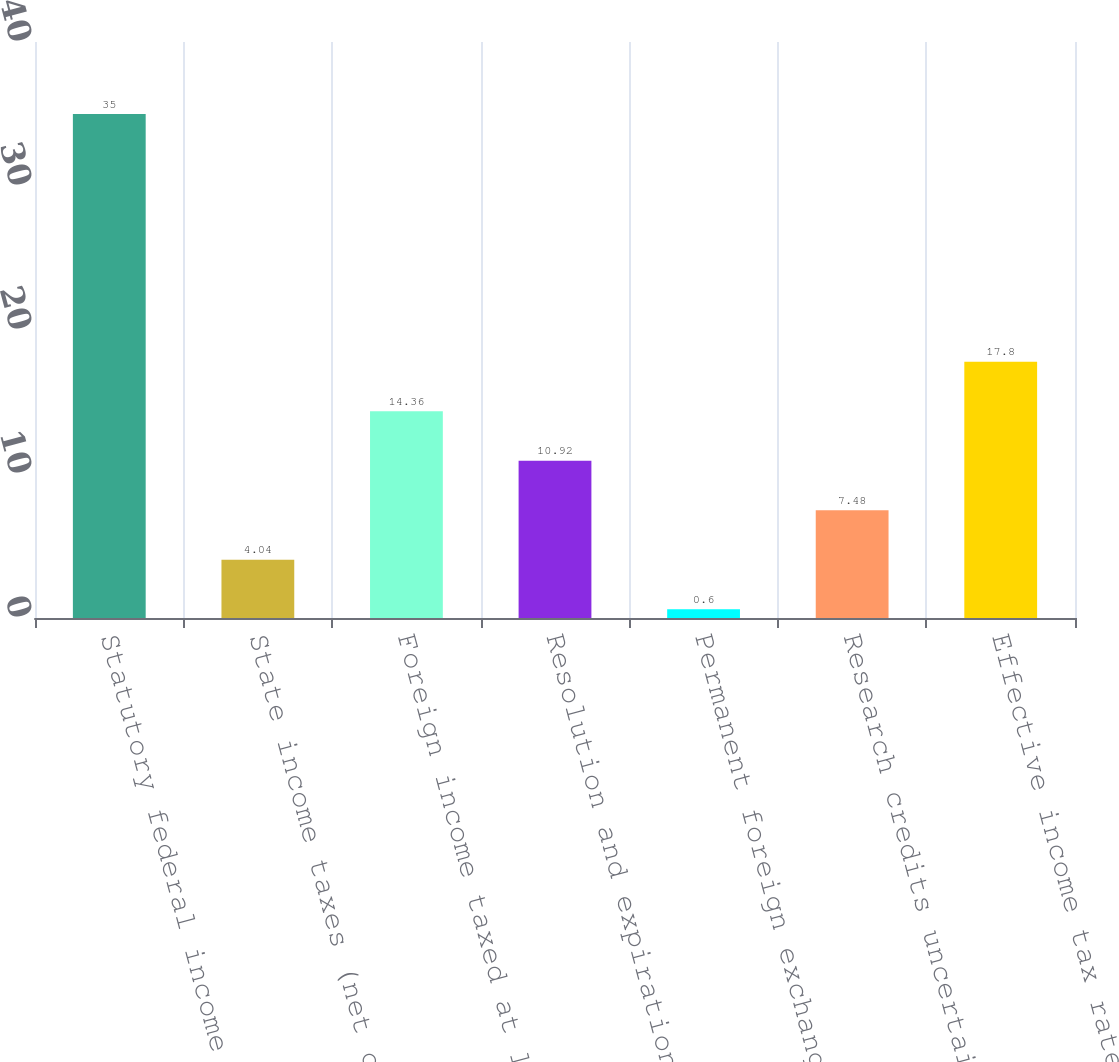<chart> <loc_0><loc_0><loc_500><loc_500><bar_chart><fcel>Statutory federal income tax<fcel>State income taxes (net of<fcel>Foreign income taxed at lower<fcel>Resolution and expiration of<fcel>Permanent foreign exchange<fcel>Research credits uncertain tax<fcel>Effective income tax rate<nl><fcel>35<fcel>4.04<fcel>14.36<fcel>10.92<fcel>0.6<fcel>7.48<fcel>17.8<nl></chart> 